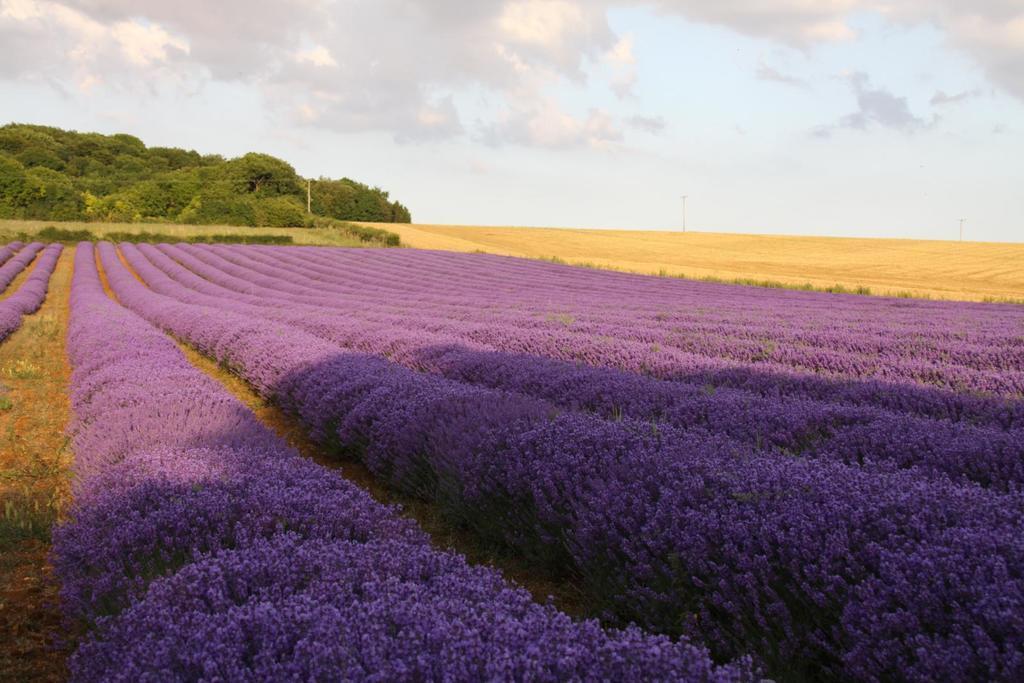Can you describe this image briefly? In this picture there is flowers field in the center of the image and there are trees at the top side of the image. 